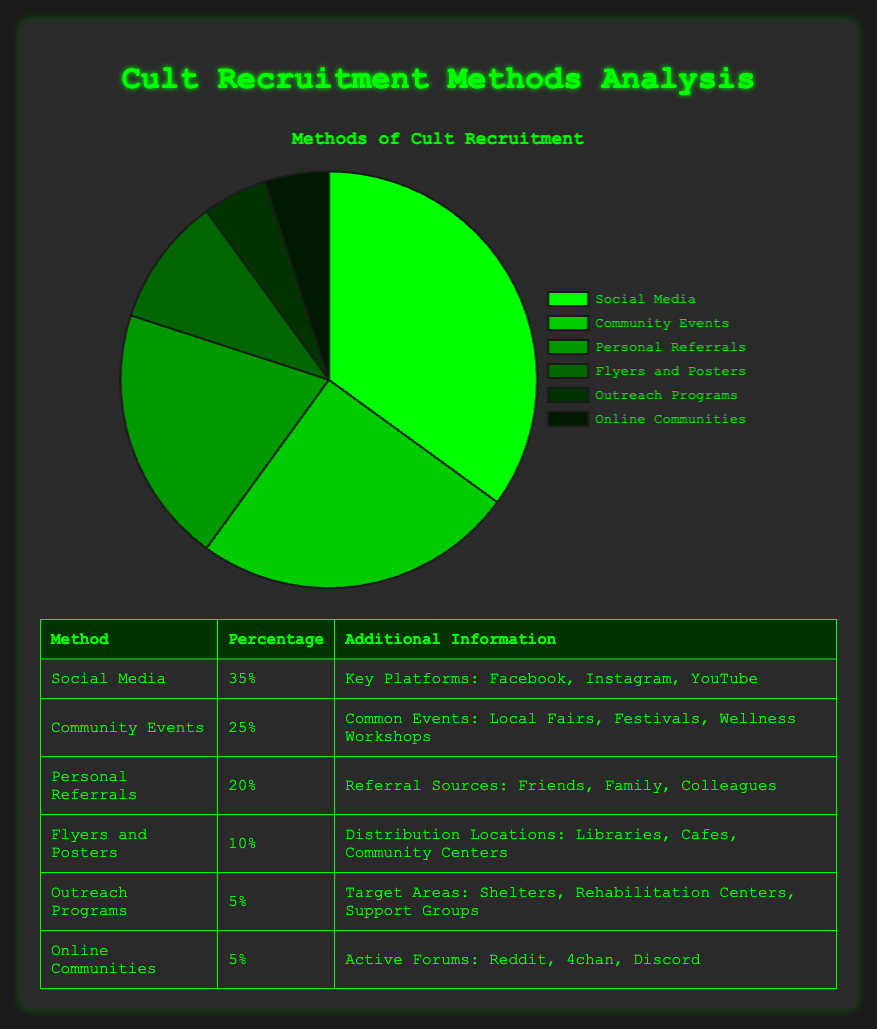what's the most common method of cult recruitment? By looking at the chart, we can see that the largest slice in the pie is for Social Media, which has a percentage of 35%. This indicates that Social Media is the most common method for cult recruitment.
Answer: Social Media What's the sum of the percentages for Outreach Programs and Online Communities? We need to find the percentages for Outreach Programs and Online Communities from the pie chart, which are 5% and 5% respectively. Adding these together gives 5% + 5% = 10%.
Answer: 10% What's the difference in recruitment percentage between Community Events and Flyers and Posters? From the pie chart, Community Events has a recruitment percentage of 25%, and Flyers and Posters have 10%. Subtracting these gives us 25% - 10% = 15%.
Answer: 15% Which method has a higher percentage: Personal Referrals or Community Events? By comparing the pie chart slices, we see that Community Events have a percentage of 25%, while Personal Referrals have 20%. Therefore, Community Events have a higher percentage than Personal Referrals.
Answer: Community Events What is the color of the graph slice representing Online Communities? By observing the pie chart, the slice for Online Communities is represented by the darkest green color.
Answer: Dark green Is the recruitment percentage for Flyers and Posters equal to the combined percentage for Outreach Programs and Online Communities? Flyers and Posters have a percentage of 10%. The combined percentage for Outreach Programs and Online Communities is 5% + 5% = 10%. Since both are 10%, the recruitment percentage is equal.
Answer: Yes What's the total percentage of recruitment from Social Media and Personal Referrals combined? To find the total percentage, add the percentages for Social Media (35%) and Personal Referrals (20%). The sum is 35% + 20% = 55%.
Answer: 55% Which methods contribute the least to cult recruitment based on the chart? We see that both Outreach Programs and Online Communities each have a slice representing 5% of the chart, which are the smallest individual percentages.
Answer: Outreach Programs and Online Communities What percentage of recruitment is done through methods other than Social Media? To find this, we subtract the percentage of Social Media from 100%, thus 100% - 35% = 65%.
Answer: 65% How many recruitment methods have a percentage above 10%? By checking the chart, we see Social Media (35%), Community Events (25%), and Personal Referrals (20%) have more than 10%. There are three such methods.
Answer: 3 